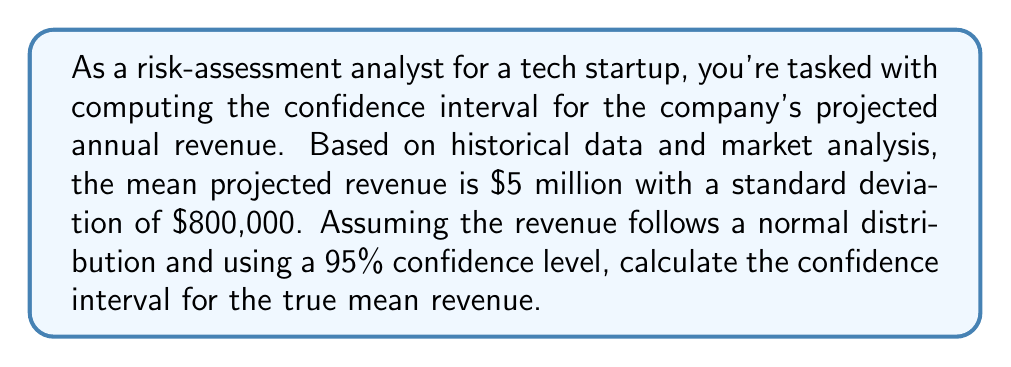What is the answer to this math problem? To compute the confidence interval, we'll follow these steps:

1) The formula for a confidence interval is:

   $$ \text{CI} = \bar{x} \pm z \cdot \frac{\sigma}{\sqrt{n}} $$

   Where:
   $\bar{x}$ is the sample mean
   $z$ is the z-score for the desired confidence level
   $\sigma$ is the population standard deviation
   $n$ is the sample size

2) We're given:
   $\bar{x} = \$5,000,000$
   $\sigma = \$800,000$
   Confidence level = 95%

3) For a 95% confidence level, the z-score is 1.96.

4) We don't have a sample size, so we'll assume we're working with the population parameters. In this case, our formula simplifies to:

   $$ \text{CI} = \mu \pm z \cdot \sigma $$

5) Plugging in our values:

   $$ \text{CI} = 5,000,000 \pm 1.96 \cdot 800,000 $$

6) Simplifying:

   $$ \text{CI} = 5,000,000 \pm 1,568,000 $$

7) Therefore, the confidence interval is:

   $$ [\$5,000,000 - \$1,568,000, \$5,000,000 + \$1,568,000] $$
   $$ [\$3,432,000, \$6,568,000] $$
Answer: The 95% confidence interval for the true mean revenue is [$3,432,000, $6,568,000]. 